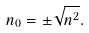<formula> <loc_0><loc_0><loc_500><loc_500>n _ { 0 } = \pm \sqrt { { n } ^ { 2 } } .</formula> 